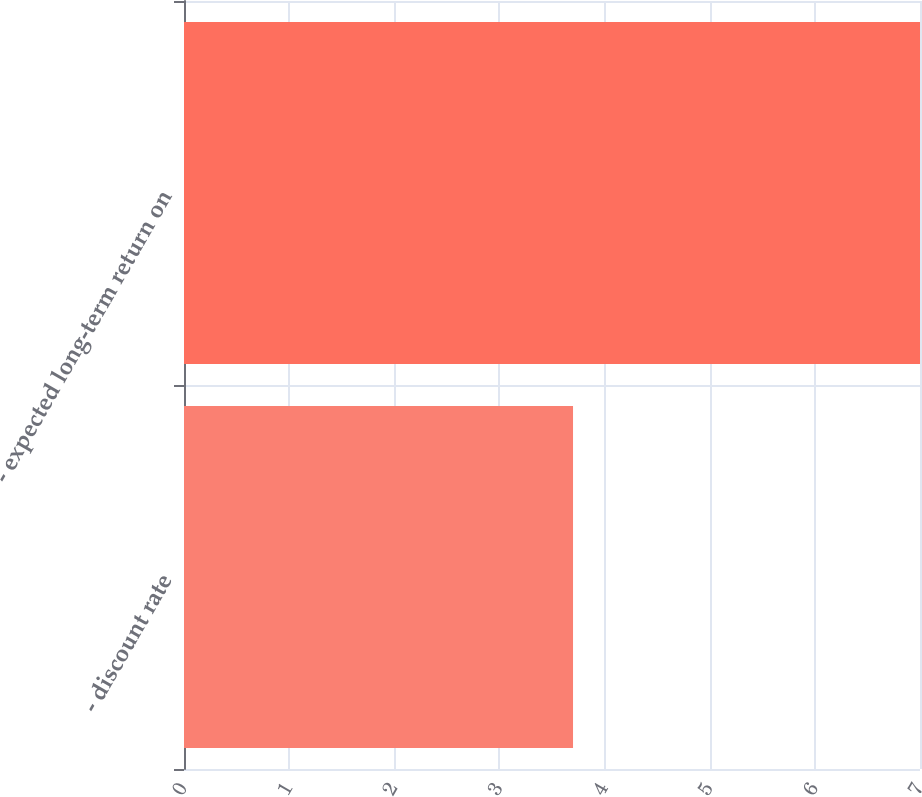Convert chart to OTSL. <chart><loc_0><loc_0><loc_500><loc_500><bar_chart><fcel>- discount rate<fcel>- expected long-term return on<nl><fcel>3.7<fcel>7<nl></chart> 